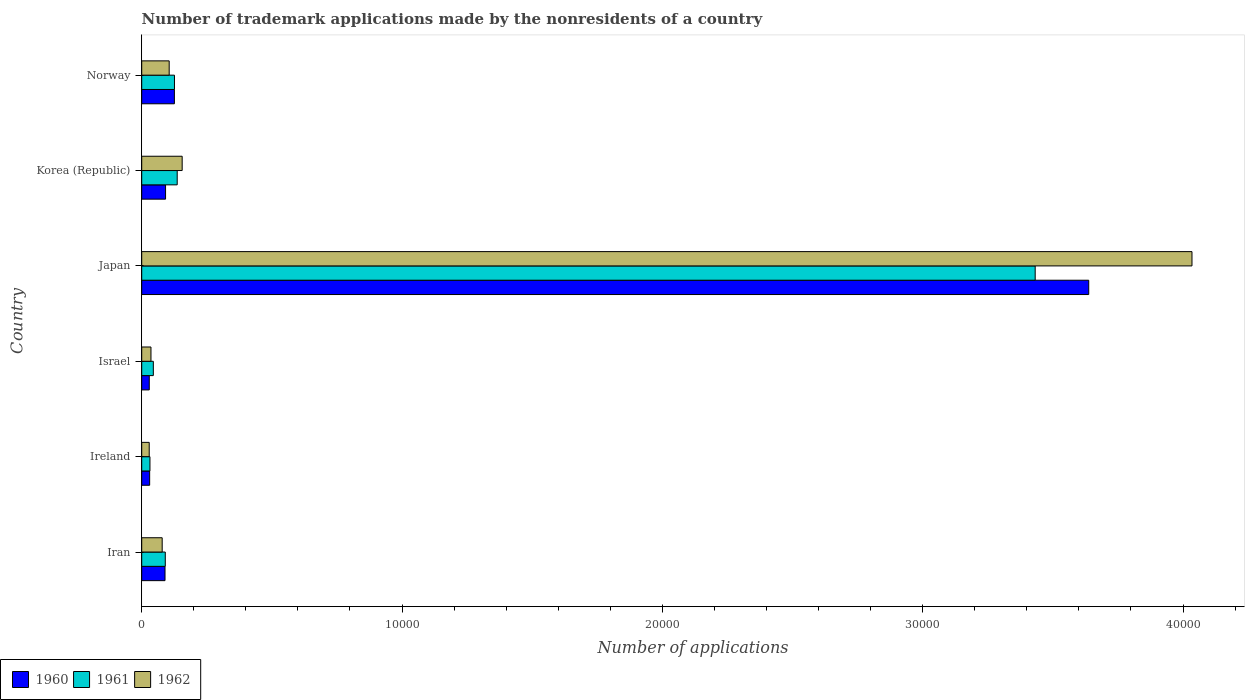How many groups of bars are there?
Your response must be concise. 6. Are the number of bars per tick equal to the number of legend labels?
Give a very brief answer. Yes. How many bars are there on the 2nd tick from the bottom?
Offer a terse response. 3. What is the number of trademark applications made by the nonresidents in 1962 in Japan?
Make the answer very short. 4.03e+04. Across all countries, what is the maximum number of trademark applications made by the nonresidents in 1961?
Provide a succinct answer. 3.43e+04. Across all countries, what is the minimum number of trademark applications made by the nonresidents in 1960?
Give a very brief answer. 290. In which country was the number of trademark applications made by the nonresidents in 1962 minimum?
Keep it short and to the point. Ireland. What is the total number of trademark applications made by the nonresidents in 1962 in the graph?
Provide a short and direct response. 4.44e+04. What is the difference between the number of trademark applications made by the nonresidents in 1961 in Korea (Republic) and that in Norway?
Offer a very short reply. 105. What is the difference between the number of trademark applications made by the nonresidents in 1960 in Norway and the number of trademark applications made by the nonresidents in 1961 in Korea (Republic)?
Ensure brevity in your answer.  -108. What is the average number of trademark applications made by the nonresidents in 1961 per country?
Ensure brevity in your answer.  6434.67. What is the difference between the number of trademark applications made by the nonresidents in 1960 and number of trademark applications made by the nonresidents in 1962 in Norway?
Keep it short and to the point. 200. In how many countries, is the number of trademark applications made by the nonresidents in 1962 greater than 8000 ?
Provide a succinct answer. 1. What is the ratio of the number of trademark applications made by the nonresidents in 1962 in Israel to that in Japan?
Ensure brevity in your answer.  0.01. Is the number of trademark applications made by the nonresidents in 1961 in Iran less than that in Israel?
Ensure brevity in your answer.  No. Is the difference between the number of trademark applications made by the nonresidents in 1960 in Israel and Korea (Republic) greater than the difference between the number of trademark applications made by the nonresidents in 1962 in Israel and Korea (Republic)?
Keep it short and to the point. Yes. What is the difference between the highest and the second highest number of trademark applications made by the nonresidents in 1961?
Offer a very short reply. 3.30e+04. What is the difference between the highest and the lowest number of trademark applications made by the nonresidents in 1960?
Your answer should be compact. 3.61e+04. In how many countries, is the number of trademark applications made by the nonresidents in 1960 greater than the average number of trademark applications made by the nonresidents in 1960 taken over all countries?
Provide a succinct answer. 1. What does the 2nd bar from the bottom in Norway represents?
Provide a succinct answer. 1961. How many bars are there?
Provide a short and direct response. 18. Are the values on the major ticks of X-axis written in scientific E-notation?
Give a very brief answer. No. How many legend labels are there?
Offer a very short reply. 3. How are the legend labels stacked?
Provide a succinct answer. Horizontal. What is the title of the graph?
Provide a succinct answer. Number of trademark applications made by the nonresidents of a country. Does "2013" appear as one of the legend labels in the graph?
Ensure brevity in your answer.  No. What is the label or title of the X-axis?
Your answer should be very brief. Number of applications. What is the Number of applications in 1960 in Iran?
Provide a succinct answer. 895. What is the Number of applications of 1961 in Iran?
Provide a short and direct response. 905. What is the Number of applications in 1962 in Iran?
Your response must be concise. 786. What is the Number of applications in 1960 in Ireland?
Your response must be concise. 305. What is the Number of applications of 1961 in Ireland?
Ensure brevity in your answer.  316. What is the Number of applications of 1962 in Ireland?
Your response must be concise. 288. What is the Number of applications in 1960 in Israel?
Keep it short and to the point. 290. What is the Number of applications in 1961 in Israel?
Keep it short and to the point. 446. What is the Number of applications of 1962 in Israel?
Provide a short and direct response. 355. What is the Number of applications in 1960 in Japan?
Give a very brief answer. 3.64e+04. What is the Number of applications in 1961 in Japan?
Your response must be concise. 3.43e+04. What is the Number of applications of 1962 in Japan?
Your answer should be compact. 4.03e+04. What is the Number of applications in 1960 in Korea (Republic)?
Keep it short and to the point. 916. What is the Number of applications in 1961 in Korea (Republic)?
Keep it short and to the point. 1363. What is the Number of applications in 1962 in Korea (Republic)?
Offer a terse response. 1554. What is the Number of applications in 1960 in Norway?
Your answer should be very brief. 1255. What is the Number of applications in 1961 in Norway?
Make the answer very short. 1258. What is the Number of applications in 1962 in Norway?
Offer a very short reply. 1055. Across all countries, what is the maximum Number of applications of 1960?
Keep it short and to the point. 3.64e+04. Across all countries, what is the maximum Number of applications in 1961?
Offer a very short reply. 3.43e+04. Across all countries, what is the maximum Number of applications in 1962?
Your response must be concise. 4.03e+04. Across all countries, what is the minimum Number of applications in 1960?
Offer a very short reply. 290. Across all countries, what is the minimum Number of applications of 1961?
Your answer should be very brief. 316. Across all countries, what is the minimum Number of applications in 1962?
Make the answer very short. 288. What is the total Number of applications of 1960 in the graph?
Offer a terse response. 4.00e+04. What is the total Number of applications of 1961 in the graph?
Make the answer very short. 3.86e+04. What is the total Number of applications in 1962 in the graph?
Give a very brief answer. 4.44e+04. What is the difference between the Number of applications of 1960 in Iran and that in Ireland?
Make the answer very short. 590. What is the difference between the Number of applications in 1961 in Iran and that in Ireland?
Keep it short and to the point. 589. What is the difference between the Number of applications in 1962 in Iran and that in Ireland?
Offer a terse response. 498. What is the difference between the Number of applications in 1960 in Iran and that in Israel?
Keep it short and to the point. 605. What is the difference between the Number of applications of 1961 in Iran and that in Israel?
Give a very brief answer. 459. What is the difference between the Number of applications of 1962 in Iran and that in Israel?
Offer a terse response. 431. What is the difference between the Number of applications in 1960 in Iran and that in Japan?
Your answer should be very brief. -3.55e+04. What is the difference between the Number of applications of 1961 in Iran and that in Japan?
Ensure brevity in your answer.  -3.34e+04. What is the difference between the Number of applications in 1962 in Iran and that in Japan?
Provide a succinct answer. -3.96e+04. What is the difference between the Number of applications in 1960 in Iran and that in Korea (Republic)?
Your answer should be compact. -21. What is the difference between the Number of applications in 1961 in Iran and that in Korea (Republic)?
Your answer should be very brief. -458. What is the difference between the Number of applications in 1962 in Iran and that in Korea (Republic)?
Provide a short and direct response. -768. What is the difference between the Number of applications in 1960 in Iran and that in Norway?
Offer a very short reply. -360. What is the difference between the Number of applications of 1961 in Iran and that in Norway?
Ensure brevity in your answer.  -353. What is the difference between the Number of applications in 1962 in Iran and that in Norway?
Give a very brief answer. -269. What is the difference between the Number of applications of 1961 in Ireland and that in Israel?
Offer a very short reply. -130. What is the difference between the Number of applications of 1962 in Ireland and that in Israel?
Your answer should be compact. -67. What is the difference between the Number of applications in 1960 in Ireland and that in Japan?
Provide a short and direct response. -3.61e+04. What is the difference between the Number of applications in 1961 in Ireland and that in Japan?
Make the answer very short. -3.40e+04. What is the difference between the Number of applications of 1962 in Ireland and that in Japan?
Give a very brief answer. -4.01e+04. What is the difference between the Number of applications of 1960 in Ireland and that in Korea (Republic)?
Ensure brevity in your answer.  -611. What is the difference between the Number of applications in 1961 in Ireland and that in Korea (Republic)?
Provide a short and direct response. -1047. What is the difference between the Number of applications of 1962 in Ireland and that in Korea (Republic)?
Provide a short and direct response. -1266. What is the difference between the Number of applications of 1960 in Ireland and that in Norway?
Offer a very short reply. -950. What is the difference between the Number of applications of 1961 in Ireland and that in Norway?
Your answer should be compact. -942. What is the difference between the Number of applications in 1962 in Ireland and that in Norway?
Offer a terse response. -767. What is the difference between the Number of applications of 1960 in Israel and that in Japan?
Your answer should be compact. -3.61e+04. What is the difference between the Number of applications in 1961 in Israel and that in Japan?
Your answer should be very brief. -3.39e+04. What is the difference between the Number of applications of 1962 in Israel and that in Japan?
Offer a very short reply. -4.00e+04. What is the difference between the Number of applications in 1960 in Israel and that in Korea (Republic)?
Offer a very short reply. -626. What is the difference between the Number of applications of 1961 in Israel and that in Korea (Republic)?
Make the answer very short. -917. What is the difference between the Number of applications in 1962 in Israel and that in Korea (Republic)?
Offer a very short reply. -1199. What is the difference between the Number of applications of 1960 in Israel and that in Norway?
Keep it short and to the point. -965. What is the difference between the Number of applications in 1961 in Israel and that in Norway?
Make the answer very short. -812. What is the difference between the Number of applications in 1962 in Israel and that in Norway?
Your response must be concise. -700. What is the difference between the Number of applications in 1960 in Japan and that in Korea (Republic)?
Offer a very short reply. 3.55e+04. What is the difference between the Number of applications in 1961 in Japan and that in Korea (Republic)?
Provide a succinct answer. 3.30e+04. What is the difference between the Number of applications in 1962 in Japan and that in Korea (Republic)?
Provide a short and direct response. 3.88e+04. What is the difference between the Number of applications in 1960 in Japan and that in Norway?
Your answer should be compact. 3.51e+04. What is the difference between the Number of applications in 1961 in Japan and that in Norway?
Provide a succinct answer. 3.31e+04. What is the difference between the Number of applications in 1962 in Japan and that in Norway?
Give a very brief answer. 3.93e+04. What is the difference between the Number of applications in 1960 in Korea (Republic) and that in Norway?
Give a very brief answer. -339. What is the difference between the Number of applications in 1961 in Korea (Republic) and that in Norway?
Ensure brevity in your answer.  105. What is the difference between the Number of applications in 1962 in Korea (Republic) and that in Norway?
Your response must be concise. 499. What is the difference between the Number of applications in 1960 in Iran and the Number of applications in 1961 in Ireland?
Give a very brief answer. 579. What is the difference between the Number of applications of 1960 in Iran and the Number of applications of 1962 in Ireland?
Offer a terse response. 607. What is the difference between the Number of applications in 1961 in Iran and the Number of applications in 1962 in Ireland?
Provide a succinct answer. 617. What is the difference between the Number of applications of 1960 in Iran and the Number of applications of 1961 in Israel?
Your response must be concise. 449. What is the difference between the Number of applications of 1960 in Iran and the Number of applications of 1962 in Israel?
Your answer should be compact. 540. What is the difference between the Number of applications of 1961 in Iran and the Number of applications of 1962 in Israel?
Provide a short and direct response. 550. What is the difference between the Number of applications in 1960 in Iran and the Number of applications in 1961 in Japan?
Your answer should be compact. -3.34e+04. What is the difference between the Number of applications of 1960 in Iran and the Number of applications of 1962 in Japan?
Keep it short and to the point. -3.94e+04. What is the difference between the Number of applications of 1961 in Iran and the Number of applications of 1962 in Japan?
Your answer should be very brief. -3.94e+04. What is the difference between the Number of applications of 1960 in Iran and the Number of applications of 1961 in Korea (Republic)?
Make the answer very short. -468. What is the difference between the Number of applications of 1960 in Iran and the Number of applications of 1962 in Korea (Republic)?
Your answer should be very brief. -659. What is the difference between the Number of applications of 1961 in Iran and the Number of applications of 1962 in Korea (Republic)?
Make the answer very short. -649. What is the difference between the Number of applications in 1960 in Iran and the Number of applications in 1961 in Norway?
Give a very brief answer. -363. What is the difference between the Number of applications in 1960 in Iran and the Number of applications in 1962 in Norway?
Provide a short and direct response. -160. What is the difference between the Number of applications of 1961 in Iran and the Number of applications of 1962 in Norway?
Offer a terse response. -150. What is the difference between the Number of applications of 1960 in Ireland and the Number of applications of 1961 in Israel?
Keep it short and to the point. -141. What is the difference between the Number of applications in 1960 in Ireland and the Number of applications in 1962 in Israel?
Keep it short and to the point. -50. What is the difference between the Number of applications of 1961 in Ireland and the Number of applications of 1962 in Israel?
Your response must be concise. -39. What is the difference between the Number of applications of 1960 in Ireland and the Number of applications of 1961 in Japan?
Make the answer very short. -3.40e+04. What is the difference between the Number of applications of 1960 in Ireland and the Number of applications of 1962 in Japan?
Give a very brief answer. -4.00e+04. What is the difference between the Number of applications of 1961 in Ireland and the Number of applications of 1962 in Japan?
Offer a very short reply. -4.00e+04. What is the difference between the Number of applications of 1960 in Ireland and the Number of applications of 1961 in Korea (Republic)?
Offer a terse response. -1058. What is the difference between the Number of applications of 1960 in Ireland and the Number of applications of 1962 in Korea (Republic)?
Your answer should be compact. -1249. What is the difference between the Number of applications in 1961 in Ireland and the Number of applications in 1962 in Korea (Republic)?
Your answer should be compact. -1238. What is the difference between the Number of applications of 1960 in Ireland and the Number of applications of 1961 in Norway?
Your answer should be compact. -953. What is the difference between the Number of applications in 1960 in Ireland and the Number of applications in 1962 in Norway?
Your answer should be compact. -750. What is the difference between the Number of applications of 1961 in Ireland and the Number of applications of 1962 in Norway?
Make the answer very short. -739. What is the difference between the Number of applications in 1960 in Israel and the Number of applications in 1961 in Japan?
Give a very brief answer. -3.40e+04. What is the difference between the Number of applications in 1960 in Israel and the Number of applications in 1962 in Japan?
Offer a terse response. -4.01e+04. What is the difference between the Number of applications of 1961 in Israel and the Number of applications of 1962 in Japan?
Your answer should be very brief. -3.99e+04. What is the difference between the Number of applications of 1960 in Israel and the Number of applications of 1961 in Korea (Republic)?
Your response must be concise. -1073. What is the difference between the Number of applications in 1960 in Israel and the Number of applications in 1962 in Korea (Republic)?
Your answer should be very brief. -1264. What is the difference between the Number of applications of 1961 in Israel and the Number of applications of 1962 in Korea (Republic)?
Give a very brief answer. -1108. What is the difference between the Number of applications of 1960 in Israel and the Number of applications of 1961 in Norway?
Offer a very short reply. -968. What is the difference between the Number of applications in 1960 in Israel and the Number of applications in 1962 in Norway?
Ensure brevity in your answer.  -765. What is the difference between the Number of applications in 1961 in Israel and the Number of applications in 1962 in Norway?
Provide a succinct answer. -609. What is the difference between the Number of applications of 1960 in Japan and the Number of applications of 1961 in Korea (Republic)?
Keep it short and to the point. 3.50e+04. What is the difference between the Number of applications of 1960 in Japan and the Number of applications of 1962 in Korea (Republic)?
Offer a terse response. 3.48e+04. What is the difference between the Number of applications in 1961 in Japan and the Number of applications in 1962 in Korea (Republic)?
Make the answer very short. 3.28e+04. What is the difference between the Number of applications in 1960 in Japan and the Number of applications in 1961 in Norway?
Offer a terse response. 3.51e+04. What is the difference between the Number of applications of 1960 in Japan and the Number of applications of 1962 in Norway?
Provide a short and direct response. 3.53e+04. What is the difference between the Number of applications of 1961 in Japan and the Number of applications of 1962 in Norway?
Provide a succinct answer. 3.33e+04. What is the difference between the Number of applications of 1960 in Korea (Republic) and the Number of applications of 1961 in Norway?
Your response must be concise. -342. What is the difference between the Number of applications in 1960 in Korea (Republic) and the Number of applications in 1962 in Norway?
Your answer should be compact. -139. What is the difference between the Number of applications of 1961 in Korea (Republic) and the Number of applications of 1962 in Norway?
Your answer should be very brief. 308. What is the average Number of applications of 1960 per country?
Offer a terse response. 6673. What is the average Number of applications of 1961 per country?
Make the answer very short. 6434.67. What is the average Number of applications in 1962 per country?
Your response must be concise. 7396.83. What is the difference between the Number of applications in 1960 and Number of applications in 1961 in Iran?
Provide a short and direct response. -10. What is the difference between the Number of applications of 1960 and Number of applications of 1962 in Iran?
Your response must be concise. 109. What is the difference between the Number of applications of 1961 and Number of applications of 1962 in Iran?
Your response must be concise. 119. What is the difference between the Number of applications in 1960 and Number of applications in 1962 in Ireland?
Your answer should be compact. 17. What is the difference between the Number of applications of 1961 and Number of applications of 1962 in Ireland?
Ensure brevity in your answer.  28. What is the difference between the Number of applications of 1960 and Number of applications of 1961 in Israel?
Offer a very short reply. -156. What is the difference between the Number of applications in 1960 and Number of applications in 1962 in Israel?
Your answer should be compact. -65. What is the difference between the Number of applications of 1961 and Number of applications of 1962 in Israel?
Your answer should be very brief. 91. What is the difference between the Number of applications of 1960 and Number of applications of 1961 in Japan?
Offer a terse response. 2057. What is the difference between the Number of applications in 1960 and Number of applications in 1962 in Japan?
Provide a succinct answer. -3966. What is the difference between the Number of applications of 1961 and Number of applications of 1962 in Japan?
Keep it short and to the point. -6023. What is the difference between the Number of applications of 1960 and Number of applications of 1961 in Korea (Republic)?
Provide a short and direct response. -447. What is the difference between the Number of applications of 1960 and Number of applications of 1962 in Korea (Republic)?
Offer a very short reply. -638. What is the difference between the Number of applications of 1961 and Number of applications of 1962 in Korea (Republic)?
Offer a very short reply. -191. What is the difference between the Number of applications of 1961 and Number of applications of 1962 in Norway?
Your response must be concise. 203. What is the ratio of the Number of applications in 1960 in Iran to that in Ireland?
Ensure brevity in your answer.  2.93. What is the ratio of the Number of applications in 1961 in Iran to that in Ireland?
Provide a short and direct response. 2.86. What is the ratio of the Number of applications in 1962 in Iran to that in Ireland?
Your answer should be very brief. 2.73. What is the ratio of the Number of applications of 1960 in Iran to that in Israel?
Provide a succinct answer. 3.09. What is the ratio of the Number of applications of 1961 in Iran to that in Israel?
Offer a terse response. 2.03. What is the ratio of the Number of applications of 1962 in Iran to that in Israel?
Provide a short and direct response. 2.21. What is the ratio of the Number of applications in 1960 in Iran to that in Japan?
Your answer should be very brief. 0.02. What is the ratio of the Number of applications in 1961 in Iran to that in Japan?
Give a very brief answer. 0.03. What is the ratio of the Number of applications in 1962 in Iran to that in Japan?
Your answer should be compact. 0.02. What is the ratio of the Number of applications in 1960 in Iran to that in Korea (Republic)?
Offer a terse response. 0.98. What is the ratio of the Number of applications in 1961 in Iran to that in Korea (Republic)?
Your answer should be very brief. 0.66. What is the ratio of the Number of applications in 1962 in Iran to that in Korea (Republic)?
Make the answer very short. 0.51. What is the ratio of the Number of applications in 1960 in Iran to that in Norway?
Provide a short and direct response. 0.71. What is the ratio of the Number of applications of 1961 in Iran to that in Norway?
Your response must be concise. 0.72. What is the ratio of the Number of applications of 1962 in Iran to that in Norway?
Ensure brevity in your answer.  0.74. What is the ratio of the Number of applications of 1960 in Ireland to that in Israel?
Give a very brief answer. 1.05. What is the ratio of the Number of applications in 1961 in Ireland to that in Israel?
Offer a very short reply. 0.71. What is the ratio of the Number of applications in 1962 in Ireland to that in Israel?
Offer a terse response. 0.81. What is the ratio of the Number of applications in 1960 in Ireland to that in Japan?
Keep it short and to the point. 0.01. What is the ratio of the Number of applications in 1961 in Ireland to that in Japan?
Offer a very short reply. 0.01. What is the ratio of the Number of applications of 1962 in Ireland to that in Japan?
Ensure brevity in your answer.  0.01. What is the ratio of the Number of applications in 1960 in Ireland to that in Korea (Republic)?
Your response must be concise. 0.33. What is the ratio of the Number of applications of 1961 in Ireland to that in Korea (Republic)?
Ensure brevity in your answer.  0.23. What is the ratio of the Number of applications of 1962 in Ireland to that in Korea (Republic)?
Your response must be concise. 0.19. What is the ratio of the Number of applications in 1960 in Ireland to that in Norway?
Give a very brief answer. 0.24. What is the ratio of the Number of applications of 1961 in Ireland to that in Norway?
Provide a succinct answer. 0.25. What is the ratio of the Number of applications of 1962 in Ireland to that in Norway?
Your answer should be compact. 0.27. What is the ratio of the Number of applications in 1960 in Israel to that in Japan?
Your answer should be compact. 0.01. What is the ratio of the Number of applications of 1961 in Israel to that in Japan?
Offer a terse response. 0.01. What is the ratio of the Number of applications of 1962 in Israel to that in Japan?
Offer a very short reply. 0.01. What is the ratio of the Number of applications in 1960 in Israel to that in Korea (Republic)?
Offer a terse response. 0.32. What is the ratio of the Number of applications in 1961 in Israel to that in Korea (Republic)?
Provide a succinct answer. 0.33. What is the ratio of the Number of applications of 1962 in Israel to that in Korea (Republic)?
Give a very brief answer. 0.23. What is the ratio of the Number of applications in 1960 in Israel to that in Norway?
Ensure brevity in your answer.  0.23. What is the ratio of the Number of applications in 1961 in Israel to that in Norway?
Make the answer very short. 0.35. What is the ratio of the Number of applications of 1962 in Israel to that in Norway?
Provide a succinct answer. 0.34. What is the ratio of the Number of applications of 1960 in Japan to that in Korea (Republic)?
Provide a short and direct response. 39.71. What is the ratio of the Number of applications of 1961 in Japan to that in Korea (Republic)?
Your response must be concise. 25.18. What is the ratio of the Number of applications of 1962 in Japan to that in Korea (Republic)?
Keep it short and to the point. 25.96. What is the ratio of the Number of applications in 1960 in Japan to that in Norway?
Your answer should be compact. 28.99. What is the ratio of the Number of applications in 1961 in Japan to that in Norway?
Your response must be concise. 27.28. What is the ratio of the Number of applications of 1962 in Japan to that in Norway?
Offer a very short reply. 38.24. What is the ratio of the Number of applications of 1960 in Korea (Republic) to that in Norway?
Offer a very short reply. 0.73. What is the ratio of the Number of applications in 1961 in Korea (Republic) to that in Norway?
Offer a terse response. 1.08. What is the ratio of the Number of applications of 1962 in Korea (Republic) to that in Norway?
Offer a terse response. 1.47. What is the difference between the highest and the second highest Number of applications of 1960?
Ensure brevity in your answer.  3.51e+04. What is the difference between the highest and the second highest Number of applications in 1961?
Provide a short and direct response. 3.30e+04. What is the difference between the highest and the second highest Number of applications of 1962?
Keep it short and to the point. 3.88e+04. What is the difference between the highest and the lowest Number of applications of 1960?
Provide a succinct answer. 3.61e+04. What is the difference between the highest and the lowest Number of applications of 1961?
Keep it short and to the point. 3.40e+04. What is the difference between the highest and the lowest Number of applications in 1962?
Your answer should be very brief. 4.01e+04. 